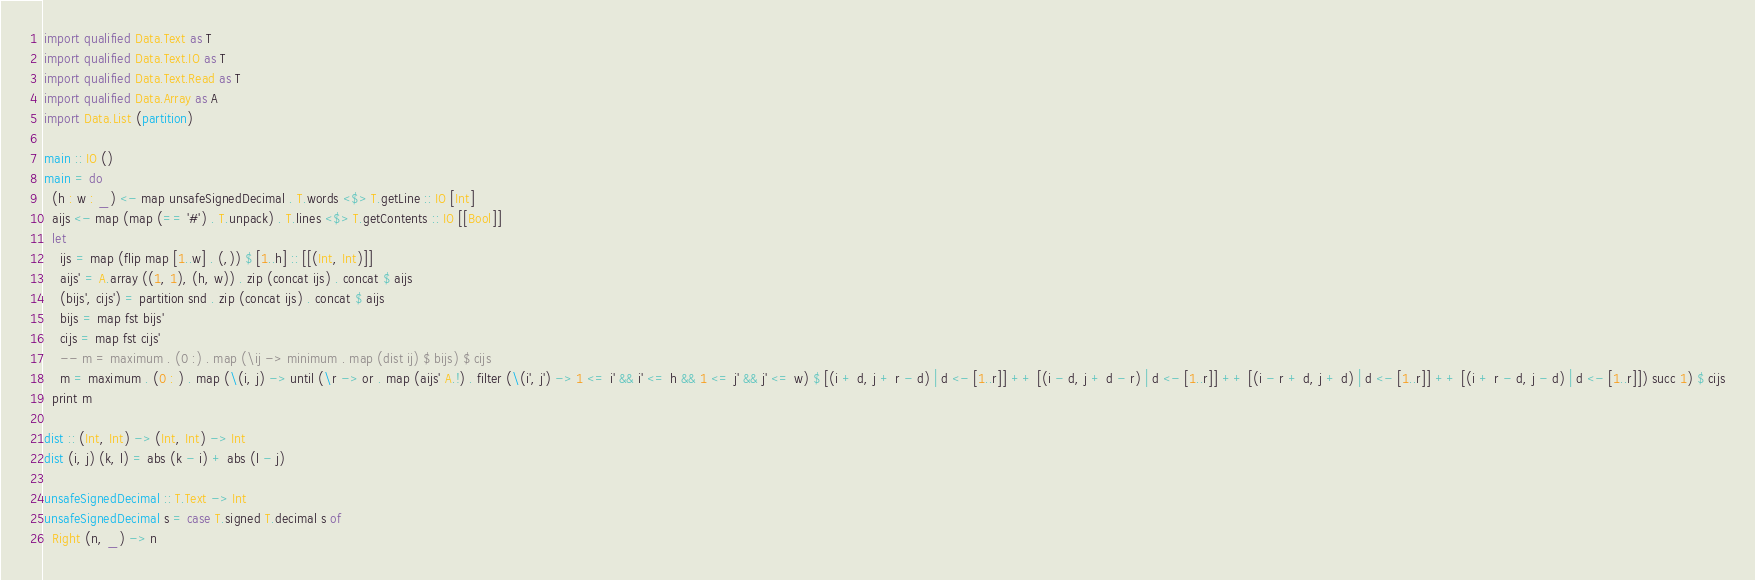<code> <loc_0><loc_0><loc_500><loc_500><_Haskell_>import qualified Data.Text as T
import qualified Data.Text.IO as T
import qualified Data.Text.Read as T
import qualified Data.Array as A
import Data.List (partition)

main :: IO ()
main = do
  (h : w : _) <- map unsafeSignedDecimal . T.words <$> T.getLine :: IO [Int]
  aijs <- map (map (== '#') . T.unpack) . T.lines <$> T.getContents :: IO [[Bool]]
  let
    ijs = map (flip map [1..w] . (,)) $ [1..h] :: [[(Int, Int)]]
    aijs' = A.array ((1, 1), (h, w)) . zip (concat ijs) . concat $ aijs
    (bijs', cijs') = partition snd . zip (concat ijs) . concat $ aijs
    bijs = map fst bijs'
    cijs = map fst cijs'
    -- m = maximum . (0 :) . map (\ij -> minimum . map (dist ij) $ bijs) $ cijs
    m = maximum . (0 : ) . map (\(i, j) -> until (\r -> or . map (aijs' A.!) . filter (\(i', j') -> 1 <= i' && i' <= h && 1 <= j' && j' <= w) $ [(i + d, j + r - d) | d <- [1..r]] ++ [(i - d, j + d - r) | d <- [1..r]] ++ [(i - r + d, j + d) | d <- [1..r]] ++ [(i + r - d, j - d) | d <- [1..r]]) succ 1) $ cijs
  print m

dist :: (Int, Int) -> (Int, Int) -> Int
dist (i, j) (k, l) = abs (k - i) + abs (l - j)

unsafeSignedDecimal :: T.Text -> Int
unsafeSignedDecimal s = case T.signed T.decimal s of
  Right (n, _) -> n
</code> 